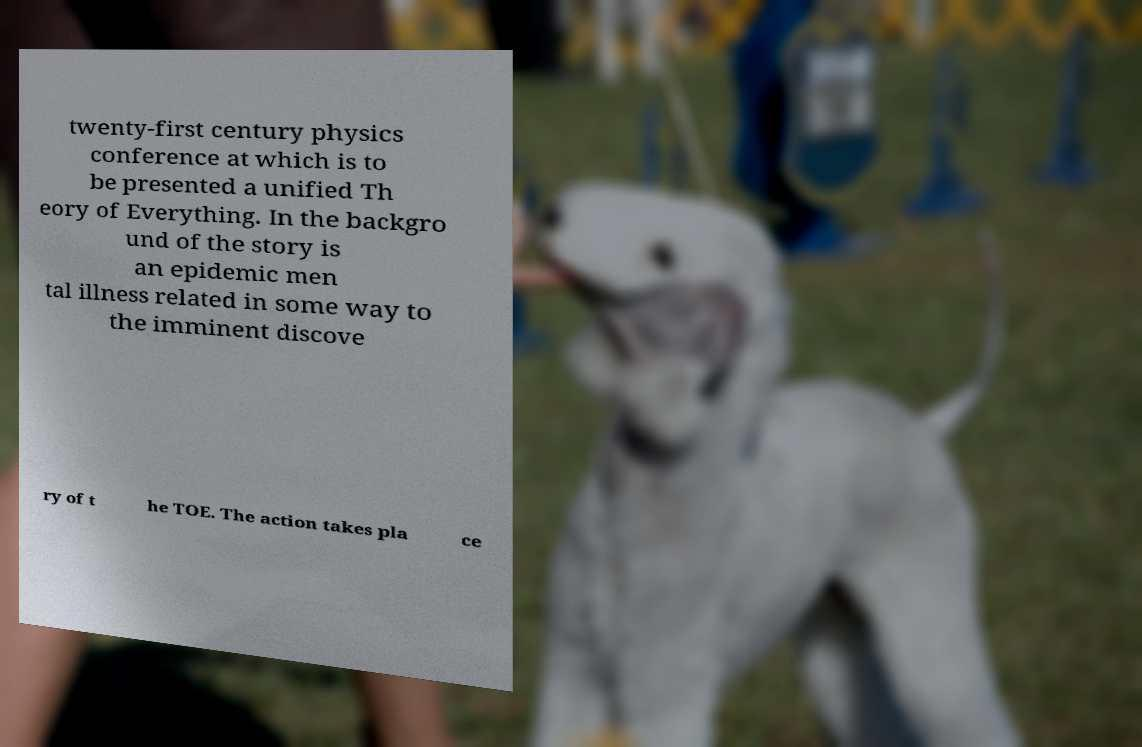Could you assist in decoding the text presented in this image and type it out clearly? twenty-first century physics conference at which is to be presented a unified Th eory of Everything. In the backgro und of the story is an epidemic men tal illness related in some way to the imminent discove ry of t he TOE. The action takes pla ce 